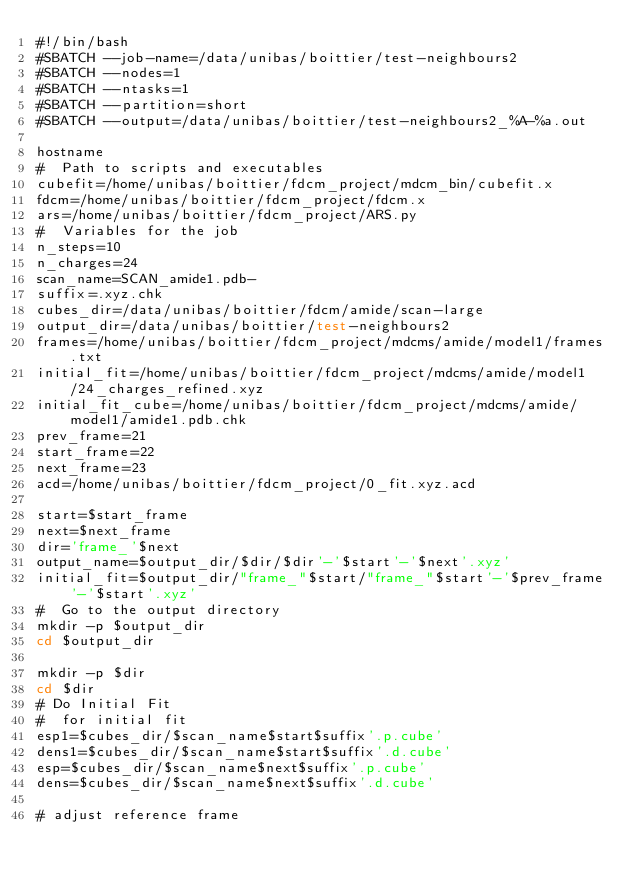<code> <loc_0><loc_0><loc_500><loc_500><_Bash_>#!/bin/bash
#SBATCH --job-name=/data/unibas/boittier/test-neighbours2
#SBATCH --nodes=1
#SBATCH --ntasks=1
#SBATCH --partition=short
#SBATCH --output=/data/unibas/boittier/test-neighbours2_%A-%a.out

hostname
#  Path to scripts and executables
cubefit=/home/unibas/boittier/fdcm_project/mdcm_bin/cubefit.x
fdcm=/home/unibas/boittier/fdcm_project/fdcm.x
ars=/home/unibas/boittier/fdcm_project/ARS.py
#  Variables for the job
n_steps=10
n_charges=24
scan_name=SCAN_amide1.pdb-
suffix=.xyz.chk
cubes_dir=/data/unibas/boittier/fdcm/amide/scan-large
output_dir=/data/unibas/boittier/test-neighbours2
frames=/home/unibas/boittier/fdcm_project/mdcms/amide/model1/frames.txt
initial_fit=/home/unibas/boittier/fdcm_project/mdcms/amide/model1/24_charges_refined.xyz
initial_fit_cube=/home/unibas/boittier/fdcm_project/mdcms/amide/model1/amide1.pdb.chk
prev_frame=21
start_frame=22
next_frame=23
acd=/home/unibas/boittier/fdcm_project/0_fit.xyz.acd

start=$start_frame
next=$next_frame
dir='frame_'$next
output_name=$output_dir/$dir/$dir'-'$start'-'$next'.xyz'
initial_fit=$output_dir/"frame_"$start/"frame_"$start'-'$prev_frame'-'$start'.xyz'
#  Go to the output directory
mkdir -p $output_dir
cd $output_dir

mkdir -p $dir
cd $dir
# Do Initial Fit
#  for initial fit
esp1=$cubes_dir/$scan_name$start$suffix'.p.cube'
dens1=$cubes_dir/$scan_name$start$suffix'.d.cube'
esp=$cubes_dir/$scan_name$next$suffix'.p.cube'
dens=$cubes_dir/$scan_name$next$suffix'.d.cube'

# adjust reference frame</code> 